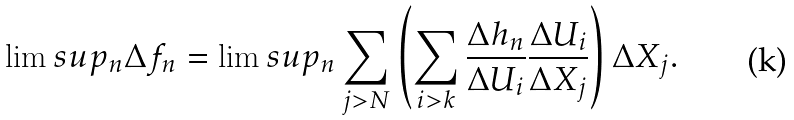<formula> <loc_0><loc_0><loc_500><loc_500>\lim s u p _ { n } \Delta f _ { n } = \lim s u p _ { n } \sum _ { j > N } \left ( \sum _ { i > k } \frac { \Delta h _ { n } } { \Delta U _ { i } } \frac { \Delta U _ { i } } { \Delta X _ { j } } \right ) \Delta X _ { j } .</formula> 